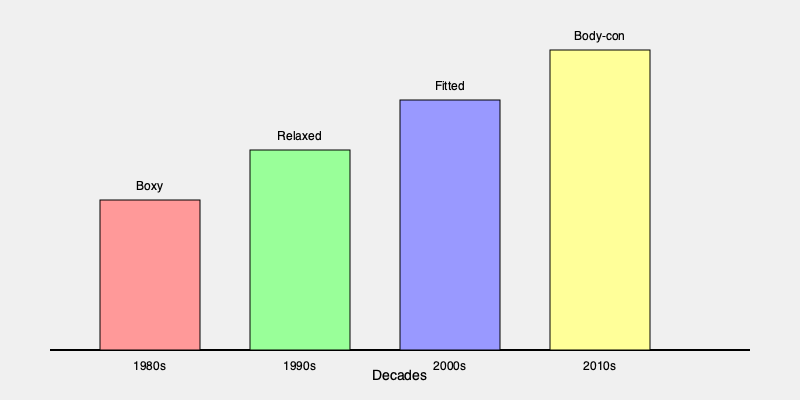Analyze the evolution of romantic comedy lead character silhouettes from the 1980s to the 2010s as depicted in the timeline infographic. What trend is observed in the silhouette's body-hugging nature, and how might this reflect changing societal attitudes towards body image and fashion in romantic comedies? To analyze the evolution of romantic comedy lead character silhouettes from the 1980s to the 2010s, we'll examine the infographic decade by decade:

1. 1980s: The silhouette is depicted as "Boxy," with a relatively short rectangle. This suggests loose-fitting, structured garments that don't closely follow the body's contours.

2. 1990s: The silhouette is labeled "Relaxed," with a taller rectangle than the 1980s. This indicates a move towards less structured, more casual clothing that still doesn't cling to the body.

3. 2000s: The silhouette is described as "Fitted," with an even taller rectangle. This suggests a shift towards clothing that follows the body's shape more closely, but still maintains some ease.

4. 2010s: The silhouette is labeled "Body-con," with the tallest rectangle. This indicates a trend towards very form-fitting, body-conscious clothing that closely hugs the wearer's figure.

The trend observed is a gradual progression from loose, boxy silhouettes to increasingly body-hugging shapes. This evolution reflects changing societal attitudes in several ways:

1. Body positivity: The move towards more fitted clothing may indicate growing acceptance and celebration of diverse body types.

2. Fashion trends: The shift aligns with general fashion trends moving from oversized looks in the 80s to more form-fitting styles in recent years.

3. Female empowerment: Tighter-fitting clothing might represent increased confidence and body autonomy for female leads in romantic comedies.

4. Changing beauty standards: The evolution could reflect shifting ideals of attractiveness in media and society.

5. Costume as character development: More fitted clothing might be used to show character growth or increased self-assurance in romantic comedy narratives.

This trend in romantic comedy costuming mirrors broader societal changes in attitudes towards body image, fashion, and self-expression over the decades.
Answer: Increasing body-hugging nature, reflecting evolving attitudes on body image and self-expression in society and media. 